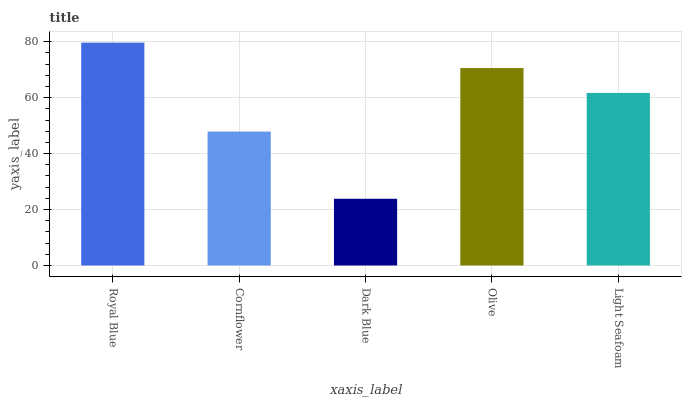Is Dark Blue the minimum?
Answer yes or no. Yes. Is Royal Blue the maximum?
Answer yes or no. Yes. Is Cornflower the minimum?
Answer yes or no. No. Is Cornflower the maximum?
Answer yes or no. No. Is Royal Blue greater than Cornflower?
Answer yes or no. Yes. Is Cornflower less than Royal Blue?
Answer yes or no. Yes. Is Cornflower greater than Royal Blue?
Answer yes or no. No. Is Royal Blue less than Cornflower?
Answer yes or no. No. Is Light Seafoam the high median?
Answer yes or no. Yes. Is Light Seafoam the low median?
Answer yes or no. Yes. Is Royal Blue the high median?
Answer yes or no. No. Is Dark Blue the low median?
Answer yes or no. No. 